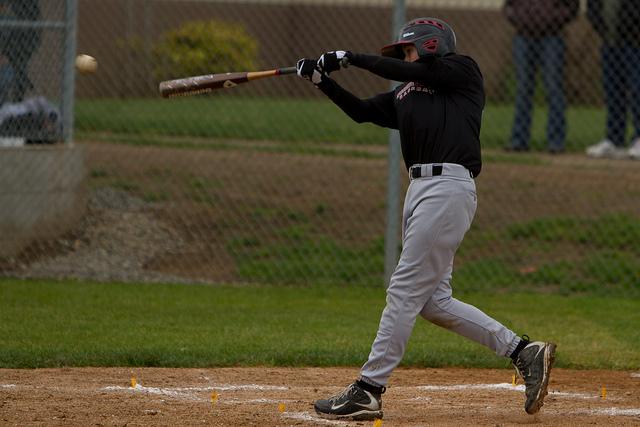What position is this person playing?
Keep it brief. Batter. Is this a child or an adult?
Write a very short answer. Child. Is this a professional sport event?
Write a very short answer. No. What type of shoes is this person wearing?
Concise answer only. Cleats. Is the batter's left knee bent?
Write a very short answer. No. What position is this man playing?
Write a very short answer. Batter. What is the man wearing?
Give a very brief answer. Uniform. 